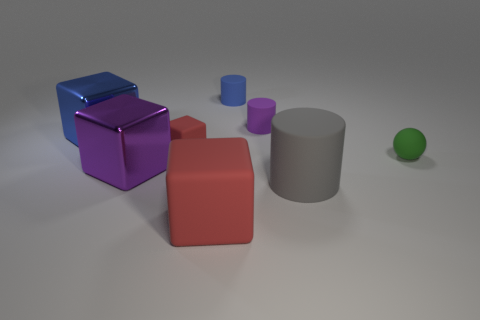Add 1 spheres. How many objects exist? 9 Subtract all yellow blocks. Subtract all green balls. How many blocks are left? 4 Subtract all cylinders. How many objects are left? 5 Add 5 big blue metal cubes. How many big blue metal cubes are left? 6 Add 2 purple rubber objects. How many purple rubber objects exist? 3 Subtract 0 brown cylinders. How many objects are left? 8 Subtract all small spheres. Subtract all large purple objects. How many objects are left? 6 